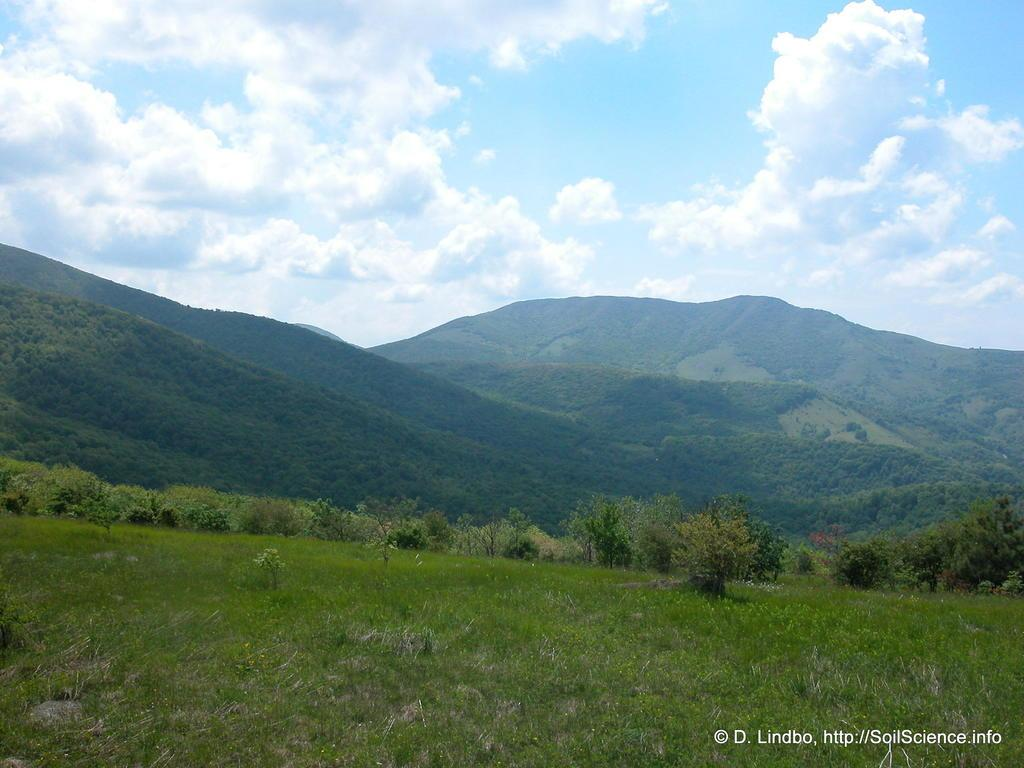What type of vegetation is at the bottom of the image? There is grass at the bottom of the image. What can be seen in the background of the image? There are trees and mountains in the background of the image. What is visible at the top of the image? The sky is visible at the top of the image. How many pancakes are being flipped by the girls in the image? There are no girls or pancakes present in the image. What type of wheel is visible in the image? There is no wheel visible in the image. 